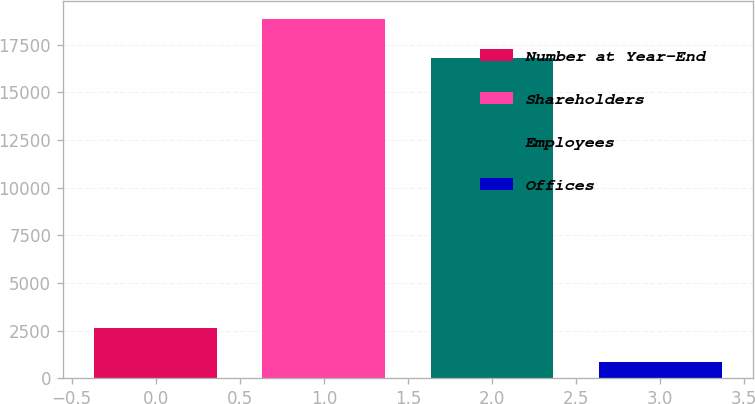Convert chart. <chart><loc_0><loc_0><loc_500><loc_500><bar_chart><fcel>Number at Year-End<fcel>Shareholders<fcel>Employees<fcel>Offices<nl><fcel>2636.1<fcel>18864<fcel>16794<fcel>833<nl></chart> 